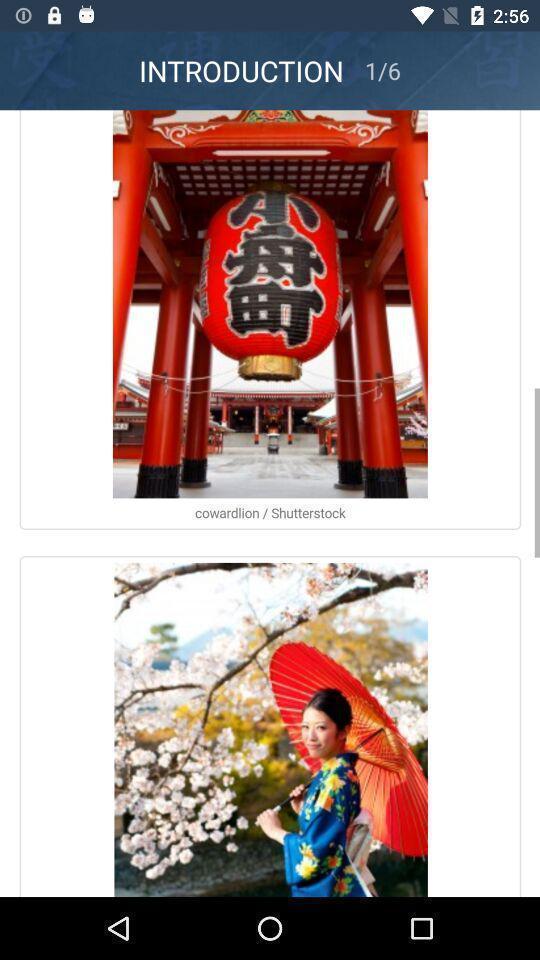Summarize the information in this screenshot. Page displaying with different images. 